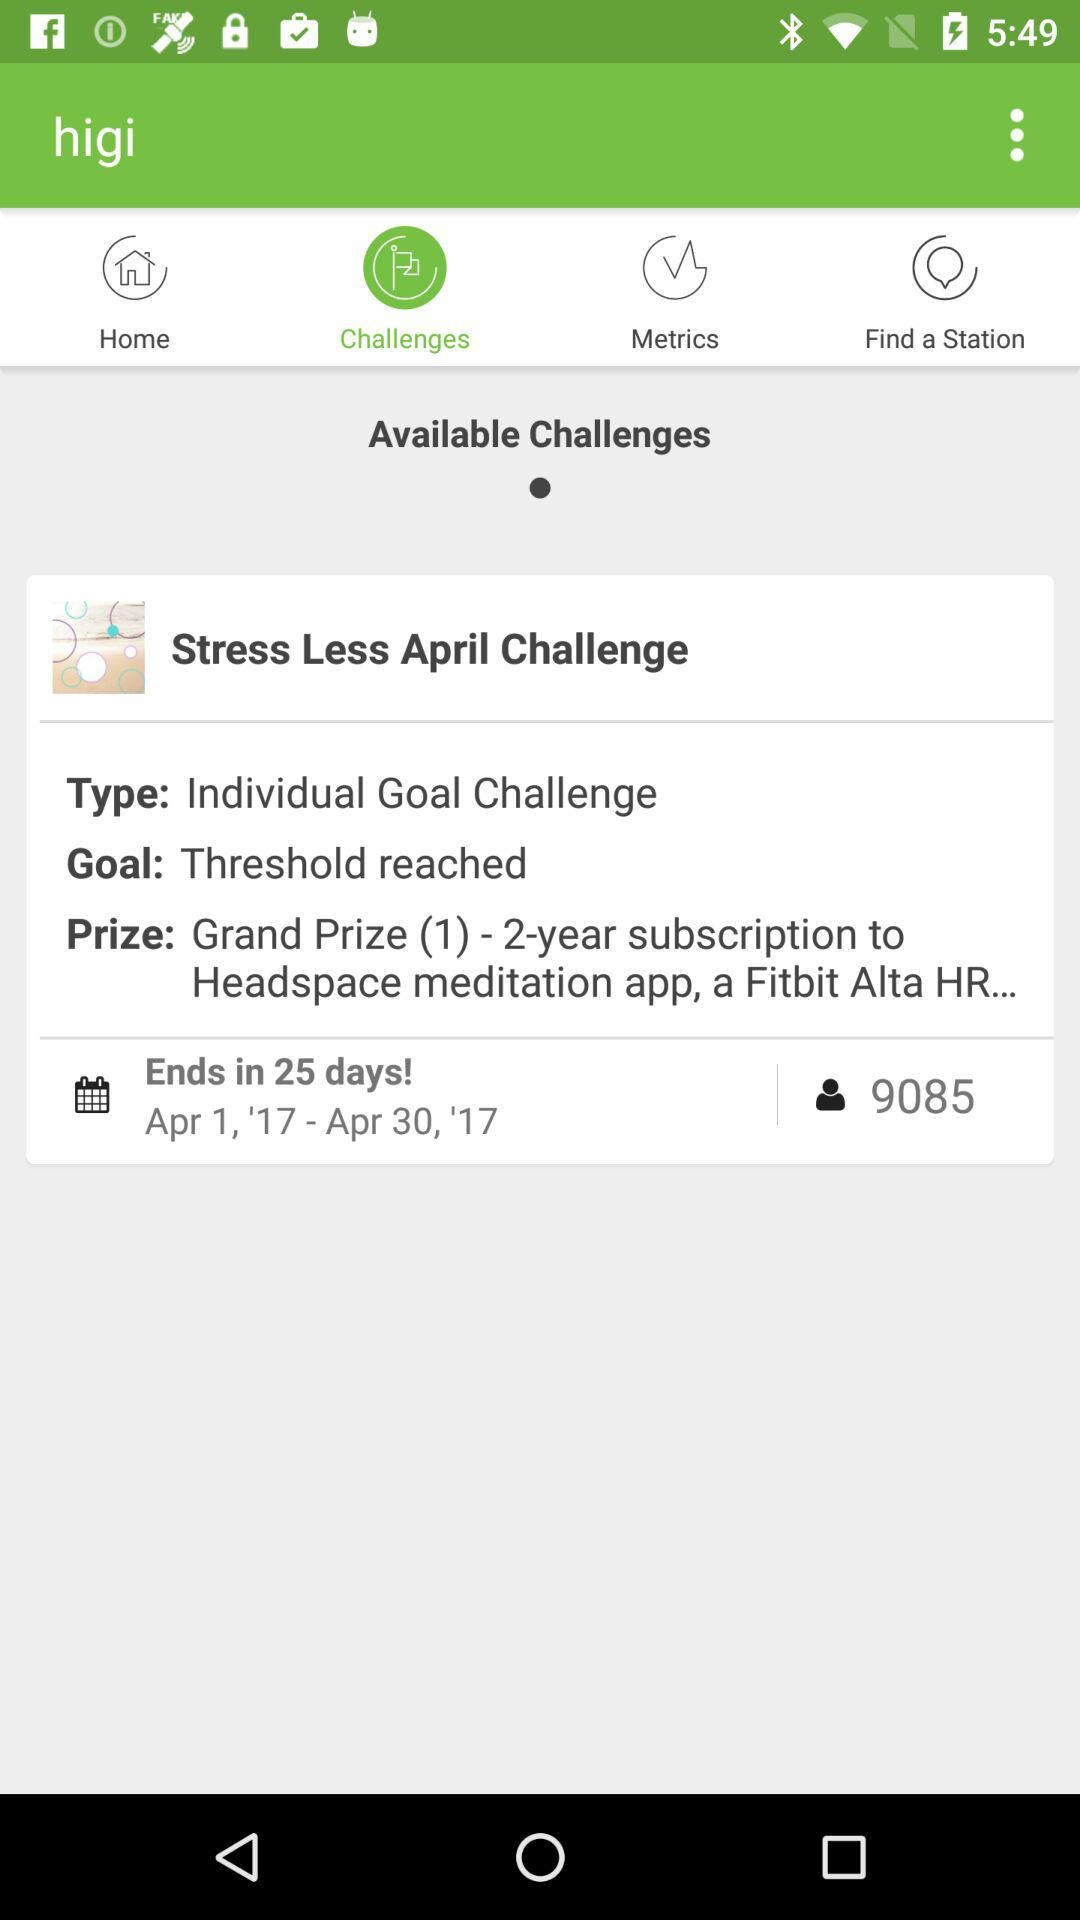How many people have registered for the challenge? The number of people who have registered for the challenge is 9085. 